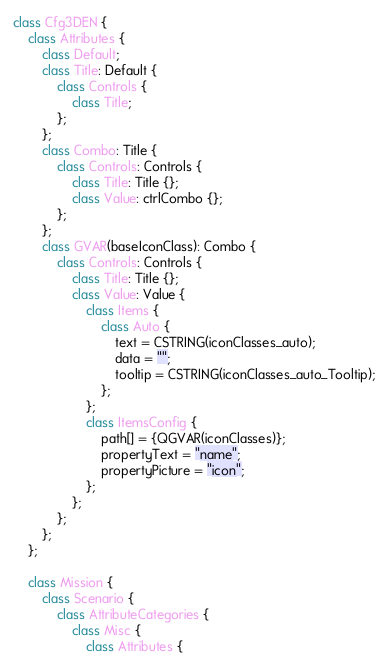Convert code to text. <code><loc_0><loc_0><loc_500><loc_500><_C++_>class Cfg3DEN {
    class Attributes {
        class Default;
		class Title: Default {
			class Controls {
				class Title;
			};
		};
        class Combo: Title {
            class Controls: Controls {
                class Title: Title {};
                class Value: ctrlCombo {};
            };
        };
        class GVAR(baseIconClass): Combo {
            class Controls: Controls {
                class Title: Title {};
                class Value: Value {
                    class Items {
                        class Auto {
                            text = CSTRING(iconClasses_auto);
                            data = "";
                            tooltip = CSTRING(iconClasses_auto_Tooltip);
                        };
                    };
                    class ItemsConfig {
                        path[] = {QGVAR(iconClasses)};
                        propertyText = "name";
                        propertyPicture = "icon";
                    };
                };
            };
        };
    };

    class Mission {
        class Scenario {
            class AttributeCategories {
                class Misc {
                    class Attributes {</code> 